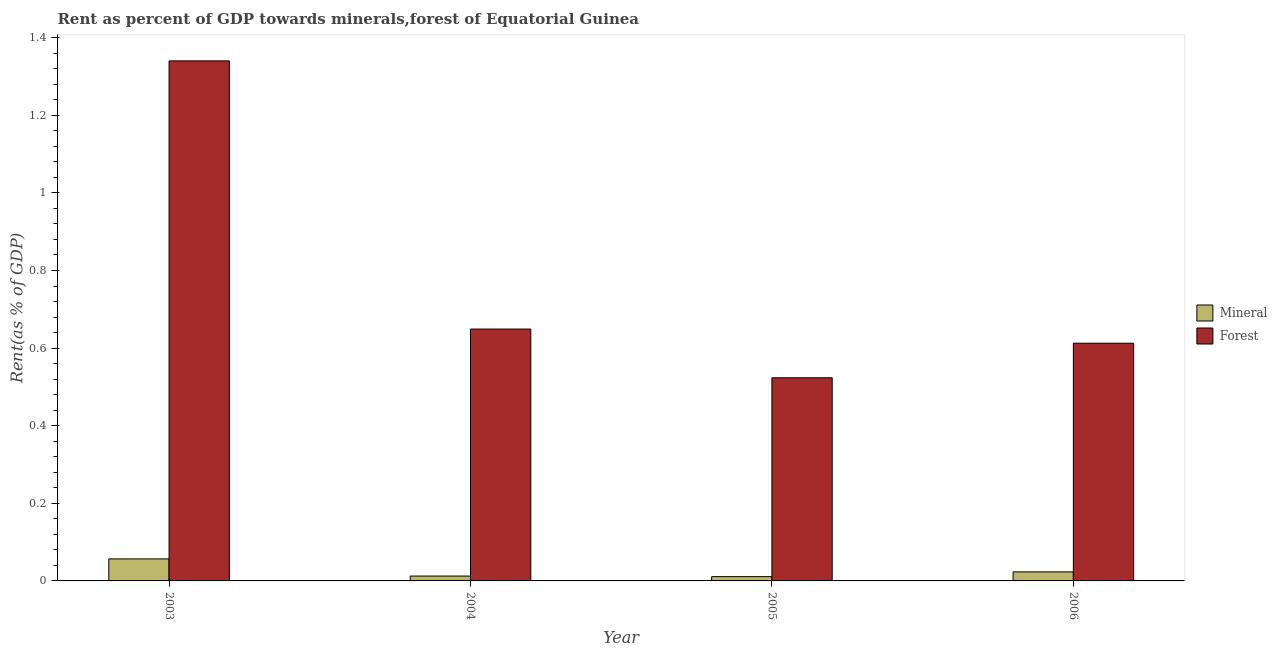How many different coloured bars are there?
Provide a short and direct response. 2. How many groups of bars are there?
Provide a short and direct response. 4. Are the number of bars on each tick of the X-axis equal?
Your response must be concise. Yes. What is the forest rent in 2006?
Your answer should be very brief. 0.61. Across all years, what is the maximum mineral rent?
Give a very brief answer. 0.06. Across all years, what is the minimum forest rent?
Provide a short and direct response. 0.52. In which year was the forest rent minimum?
Offer a very short reply. 2005. What is the total mineral rent in the graph?
Make the answer very short. 0.1. What is the difference between the forest rent in 2003 and that in 2006?
Your answer should be compact. 0.73. What is the difference between the mineral rent in 2005 and the forest rent in 2006?
Your answer should be compact. -0.01. What is the average forest rent per year?
Provide a short and direct response. 0.78. In how many years, is the mineral rent greater than 0.52 %?
Your response must be concise. 0. What is the ratio of the forest rent in 2005 to that in 2006?
Provide a short and direct response. 0.85. What is the difference between the highest and the second highest forest rent?
Make the answer very short. 0.69. What is the difference between the highest and the lowest forest rent?
Give a very brief answer. 0.82. In how many years, is the mineral rent greater than the average mineral rent taken over all years?
Offer a terse response. 1. Is the sum of the mineral rent in 2003 and 2006 greater than the maximum forest rent across all years?
Provide a succinct answer. Yes. What does the 2nd bar from the left in 2005 represents?
Provide a succinct answer. Forest. What does the 1st bar from the right in 2006 represents?
Make the answer very short. Forest. Are all the bars in the graph horizontal?
Provide a short and direct response. No. What is the difference between two consecutive major ticks on the Y-axis?
Provide a short and direct response. 0.2. Does the graph contain any zero values?
Your response must be concise. No. Does the graph contain grids?
Your answer should be very brief. No. How are the legend labels stacked?
Provide a succinct answer. Vertical. What is the title of the graph?
Your answer should be compact. Rent as percent of GDP towards minerals,forest of Equatorial Guinea. What is the label or title of the Y-axis?
Make the answer very short. Rent(as % of GDP). What is the Rent(as % of GDP) in Mineral in 2003?
Provide a short and direct response. 0.06. What is the Rent(as % of GDP) of Forest in 2003?
Your response must be concise. 1.34. What is the Rent(as % of GDP) of Mineral in 2004?
Offer a very short reply. 0.01. What is the Rent(as % of GDP) in Forest in 2004?
Make the answer very short. 0.65. What is the Rent(as % of GDP) of Mineral in 2005?
Make the answer very short. 0.01. What is the Rent(as % of GDP) in Forest in 2005?
Your answer should be compact. 0.52. What is the Rent(as % of GDP) in Mineral in 2006?
Offer a terse response. 0.02. What is the Rent(as % of GDP) in Forest in 2006?
Your response must be concise. 0.61. Across all years, what is the maximum Rent(as % of GDP) of Mineral?
Give a very brief answer. 0.06. Across all years, what is the maximum Rent(as % of GDP) of Forest?
Offer a terse response. 1.34. Across all years, what is the minimum Rent(as % of GDP) in Mineral?
Offer a terse response. 0.01. Across all years, what is the minimum Rent(as % of GDP) of Forest?
Ensure brevity in your answer.  0.52. What is the total Rent(as % of GDP) in Mineral in the graph?
Give a very brief answer. 0.1. What is the total Rent(as % of GDP) in Forest in the graph?
Offer a terse response. 3.13. What is the difference between the Rent(as % of GDP) of Mineral in 2003 and that in 2004?
Provide a short and direct response. 0.04. What is the difference between the Rent(as % of GDP) in Forest in 2003 and that in 2004?
Provide a succinct answer. 0.69. What is the difference between the Rent(as % of GDP) in Mineral in 2003 and that in 2005?
Your response must be concise. 0.05. What is the difference between the Rent(as % of GDP) in Forest in 2003 and that in 2005?
Keep it short and to the point. 0.82. What is the difference between the Rent(as % of GDP) in Mineral in 2003 and that in 2006?
Keep it short and to the point. 0.03. What is the difference between the Rent(as % of GDP) in Forest in 2003 and that in 2006?
Your response must be concise. 0.73. What is the difference between the Rent(as % of GDP) of Mineral in 2004 and that in 2005?
Your answer should be compact. 0. What is the difference between the Rent(as % of GDP) in Forest in 2004 and that in 2005?
Your answer should be very brief. 0.13. What is the difference between the Rent(as % of GDP) of Mineral in 2004 and that in 2006?
Your answer should be compact. -0.01. What is the difference between the Rent(as % of GDP) in Forest in 2004 and that in 2006?
Ensure brevity in your answer.  0.04. What is the difference between the Rent(as % of GDP) of Mineral in 2005 and that in 2006?
Offer a very short reply. -0.01. What is the difference between the Rent(as % of GDP) of Forest in 2005 and that in 2006?
Your answer should be compact. -0.09. What is the difference between the Rent(as % of GDP) of Mineral in 2003 and the Rent(as % of GDP) of Forest in 2004?
Your response must be concise. -0.59. What is the difference between the Rent(as % of GDP) in Mineral in 2003 and the Rent(as % of GDP) in Forest in 2005?
Your answer should be compact. -0.47. What is the difference between the Rent(as % of GDP) in Mineral in 2003 and the Rent(as % of GDP) in Forest in 2006?
Your answer should be compact. -0.56. What is the difference between the Rent(as % of GDP) in Mineral in 2004 and the Rent(as % of GDP) in Forest in 2005?
Give a very brief answer. -0.51. What is the difference between the Rent(as % of GDP) of Mineral in 2004 and the Rent(as % of GDP) of Forest in 2006?
Make the answer very short. -0.6. What is the difference between the Rent(as % of GDP) of Mineral in 2005 and the Rent(as % of GDP) of Forest in 2006?
Provide a succinct answer. -0.6. What is the average Rent(as % of GDP) in Mineral per year?
Provide a succinct answer. 0.03. What is the average Rent(as % of GDP) of Forest per year?
Keep it short and to the point. 0.78. In the year 2003, what is the difference between the Rent(as % of GDP) of Mineral and Rent(as % of GDP) of Forest?
Offer a terse response. -1.28. In the year 2004, what is the difference between the Rent(as % of GDP) of Mineral and Rent(as % of GDP) of Forest?
Provide a succinct answer. -0.64. In the year 2005, what is the difference between the Rent(as % of GDP) of Mineral and Rent(as % of GDP) of Forest?
Provide a succinct answer. -0.51. In the year 2006, what is the difference between the Rent(as % of GDP) in Mineral and Rent(as % of GDP) in Forest?
Make the answer very short. -0.59. What is the ratio of the Rent(as % of GDP) of Mineral in 2003 to that in 2004?
Give a very brief answer. 4.53. What is the ratio of the Rent(as % of GDP) in Forest in 2003 to that in 2004?
Ensure brevity in your answer.  2.06. What is the ratio of the Rent(as % of GDP) of Mineral in 2003 to that in 2005?
Keep it short and to the point. 5.14. What is the ratio of the Rent(as % of GDP) of Forest in 2003 to that in 2005?
Provide a succinct answer. 2.56. What is the ratio of the Rent(as % of GDP) in Mineral in 2003 to that in 2006?
Your answer should be compact. 2.44. What is the ratio of the Rent(as % of GDP) of Forest in 2003 to that in 2006?
Offer a terse response. 2.19. What is the ratio of the Rent(as % of GDP) of Mineral in 2004 to that in 2005?
Your answer should be compact. 1.14. What is the ratio of the Rent(as % of GDP) in Forest in 2004 to that in 2005?
Your answer should be compact. 1.24. What is the ratio of the Rent(as % of GDP) in Mineral in 2004 to that in 2006?
Offer a very short reply. 0.54. What is the ratio of the Rent(as % of GDP) in Forest in 2004 to that in 2006?
Offer a terse response. 1.06. What is the ratio of the Rent(as % of GDP) of Mineral in 2005 to that in 2006?
Provide a succinct answer. 0.47. What is the ratio of the Rent(as % of GDP) in Forest in 2005 to that in 2006?
Provide a succinct answer. 0.85. What is the difference between the highest and the second highest Rent(as % of GDP) in Mineral?
Keep it short and to the point. 0.03. What is the difference between the highest and the second highest Rent(as % of GDP) in Forest?
Provide a short and direct response. 0.69. What is the difference between the highest and the lowest Rent(as % of GDP) of Mineral?
Keep it short and to the point. 0.05. What is the difference between the highest and the lowest Rent(as % of GDP) of Forest?
Make the answer very short. 0.82. 